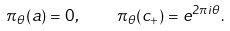<formula> <loc_0><loc_0><loc_500><loc_500>\pi _ { \theta } ( a ) = 0 , \quad \pi _ { \theta } ( c _ { + } ) = e ^ { 2 \pi i \theta } .</formula> 